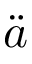Convert formula to latex. <formula><loc_0><loc_0><loc_500><loc_500>\ddot { a }</formula> 